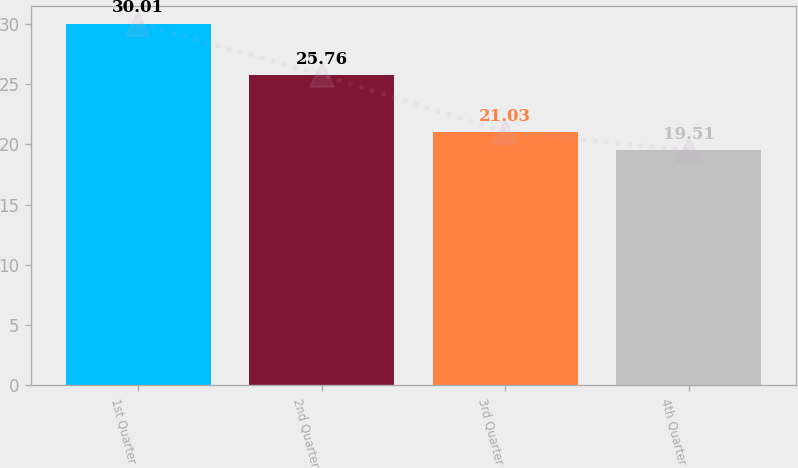<chart> <loc_0><loc_0><loc_500><loc_500><bar_chart><fcel>1st Quarter<fcel>2nd Quarter<fcel>3rd Quarter<fcel>4th Quarter<nl><fcel>30.01<fcel>25.76<fcel>21.03<fcel>19.51<nl></chart> 